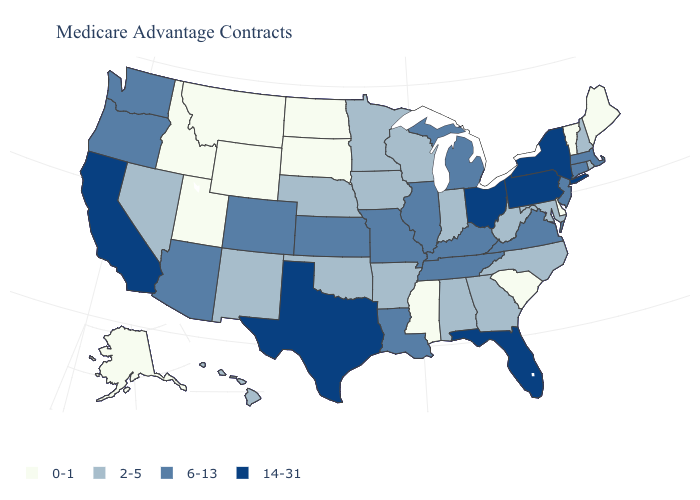What is the highest value in the MidWest ?
Short answer required. 14-31. Name the states that have a value in the range 6-13?
Give a very brief answer. Arizona, Colorado, Connecticut, Illinois, Kansas, Kentucky, Louisiana, Massachusetts, Michigan, Missouri, New Jersey, Oregon, Tennessee, Virginia, Washington. Which states have the highest value in the USA?
Quick response, please. California, Florida, New York, Ohio, Pennsylvania, Texas. Among the states that border Ohio , which have the lowest value?
Keep it brief. Indiana, West Virginia. Which states have the lowest value in the West?
Give a very brief answer. Alaska, Idaho, Montana, Utah, Wyoming. What is the value of Mississippi?
Answer briefly. 0-1. What is the value of Oregon?
Be succinct. 6-13. Does the map have missing data?
Give a very brief answer. No. Does Maine have the lowest value in the Northeast?
Keep it brief. Yes. Does Rhode Island have the same value as Florida?
Concise answer only. No. Among the states that border Delaware , does Pennsylvania have the highest value?
Write a very short answer. Yes. Name the states that have a value in the range 0-1?
Short answer required. Alaska, Delaware, Idaho, Maine, Mississippi, Montana, North Dakota, South Carolina, South Dakota, Utah, Vermont, Wyoming. Among the states that border Rhode Island , which have the lowest value?
Keep it brief. Connecticut, Massachusetts. Which states hav the highest value in the Northeast?
Concise answer only. New York, Pennsylvania. 